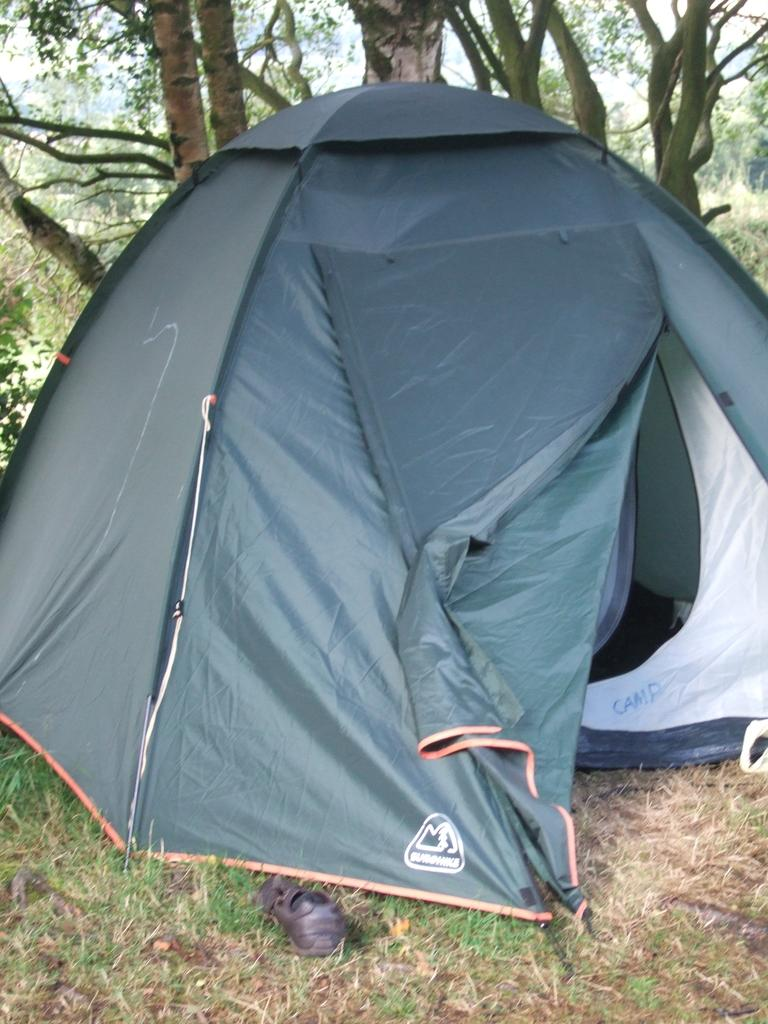What structure can be seen in the image? There is a tent in the image. What can be seen in the distance behind the tent? There are trees and grass visible in the background of the image. What is on the ground in the image? There is something on the ground in the image, but the specifics are not mentioned in the facts. Can you tell me how many ducks are on the stage in the image? There is no stage or ducks present in the image. What type of base is supporting the tent in the image? The facts do not mention any specific base supporting the tent, so we cannot determine its type. 